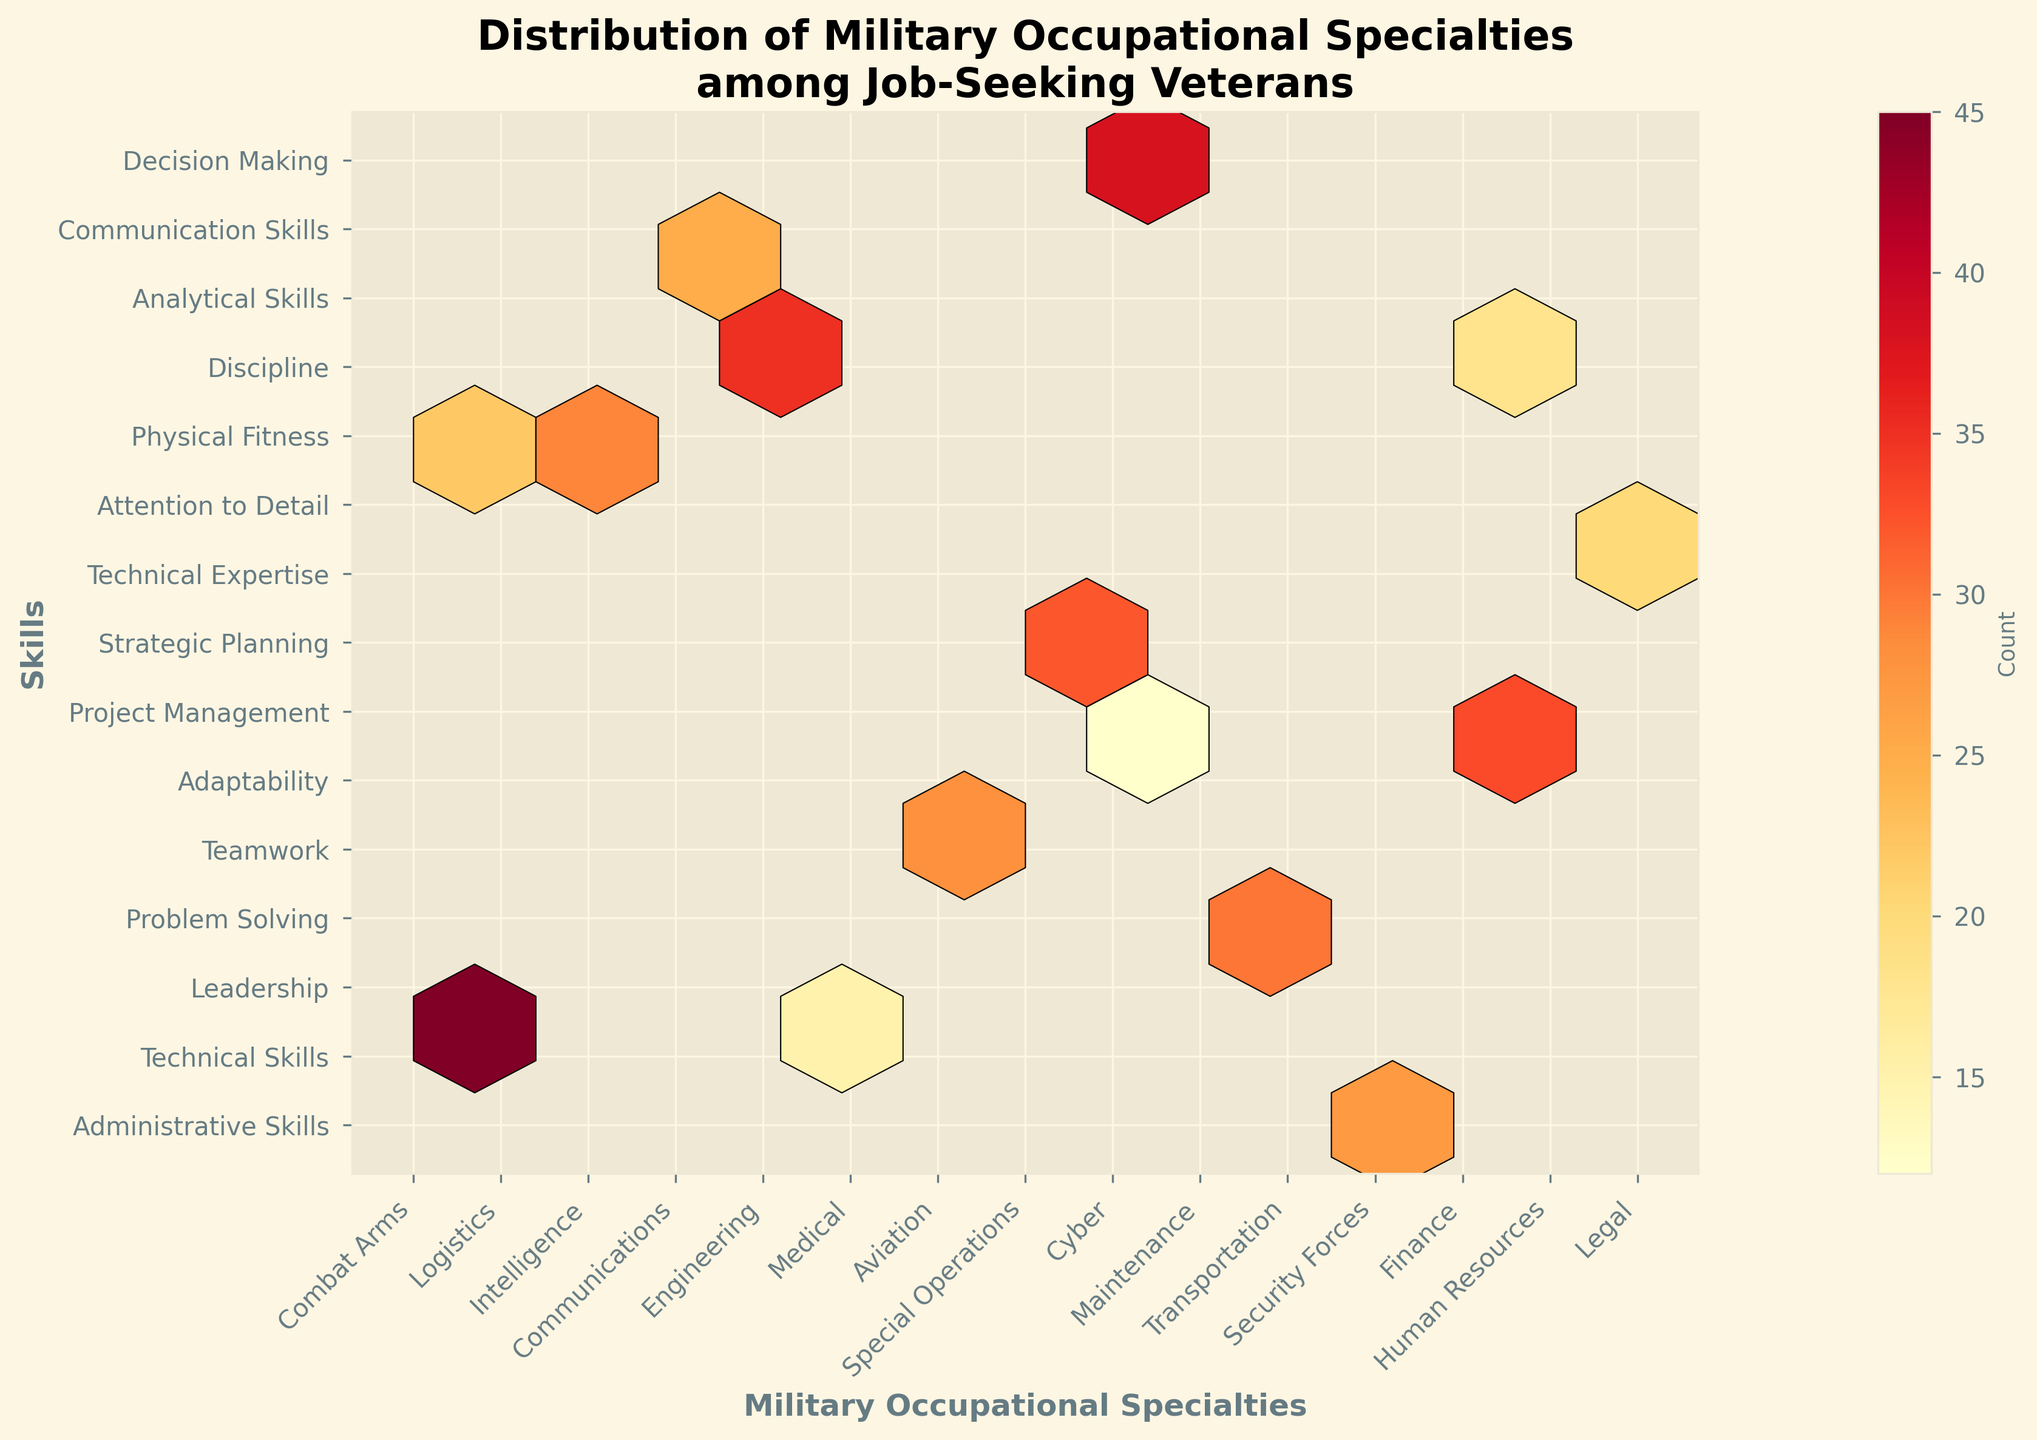What is the title of the plot? The title is usually located at the top of the figure and provides a summary of what the figure is about. Here, it mentions the "Distribution of Military Occupational Specialties among Job-Seeking Veterans".
Answer: Distribution of Military Occupational Specialties among Job-Seeking Veterans Which military occupational specialty has the highest count of job-seeking veterans with administrative skills? Locate "Administrative Skills" on the y-axis of the plot, then find the hexbin with the highest count on that row. The corresponding label on the x-axis is the answer.
Answer: Combat Arms How many categories are there for military occupational specialties? Count the number of unique labels on the x-axis to determine the total number of military occupational specialties represented in the plot.
Answer: 15 Which skills category has the lowest number of job-seeking veterans from the finance specialty? Locate "Finance" on the x-axis and then find the smallest hexbin count in that column. The corresponding label on the y-axis is the answer.
Answer: Decision Making What is the color range used to depict the count of job-seeking veterans in the hexbin plots? The color range usually includes a spectrum from lighter to darker shades which indicate different counts. In this plot, the colors range from light yellow (low count) to dark red (high count), typically depicted by the 'YlOrRd' colormap.
Answer: Light yellow to dark red Which skill has the highest number of job-seeking veterans with an engineering background? Locate "Engineering" on the x-axis of the plot and find the hexbin with the highest count in that column. The corresponding label on the y-axis is the answer.
Answer: Teamwork Which military occupational specialty has the fewest job-seeking veterans in the adaptability skill category? Locate "Adaptability" on the y-axis and find the hexbin with the lowest count in that row. The corresponding label on the x-axis is the answer.
Answer: Medical What is the average count of job-seeking veterans for the technical skills category across all military occupational specialties? Sum up all the count values in the "Technical Skills" row and divide by the number of military occupational specialties. (38 + 0 + 25 + 0 + 0 + 0 + 0 + 0 + 0 + 0 + 0 + 0 + 0 + 0 + 0) / 15 = 63/15 ≈ 4.2
Answer: 4.2 Compare the count of job-seeking veterans with leadership skills from the intelligence specialty to those with communication skills from the human resources specialty. Which is greater? Find the counts for "Intelligence" + "Leadership" and "Human Resources" + "Communication Skills", then compare them: 32 (Intelligence + Leadership) and 28 (Human Resources + Communication Skills).
Answer: Intelligence + Leadership What is the sum of job-seeking veterans in the problem-solving skill category across all military occupational specialties? Sum up all the counts in the "Problem Solving" row. Since there is only one non-zero count (Communications), the sum is just this value: 29.
Answer: 29 